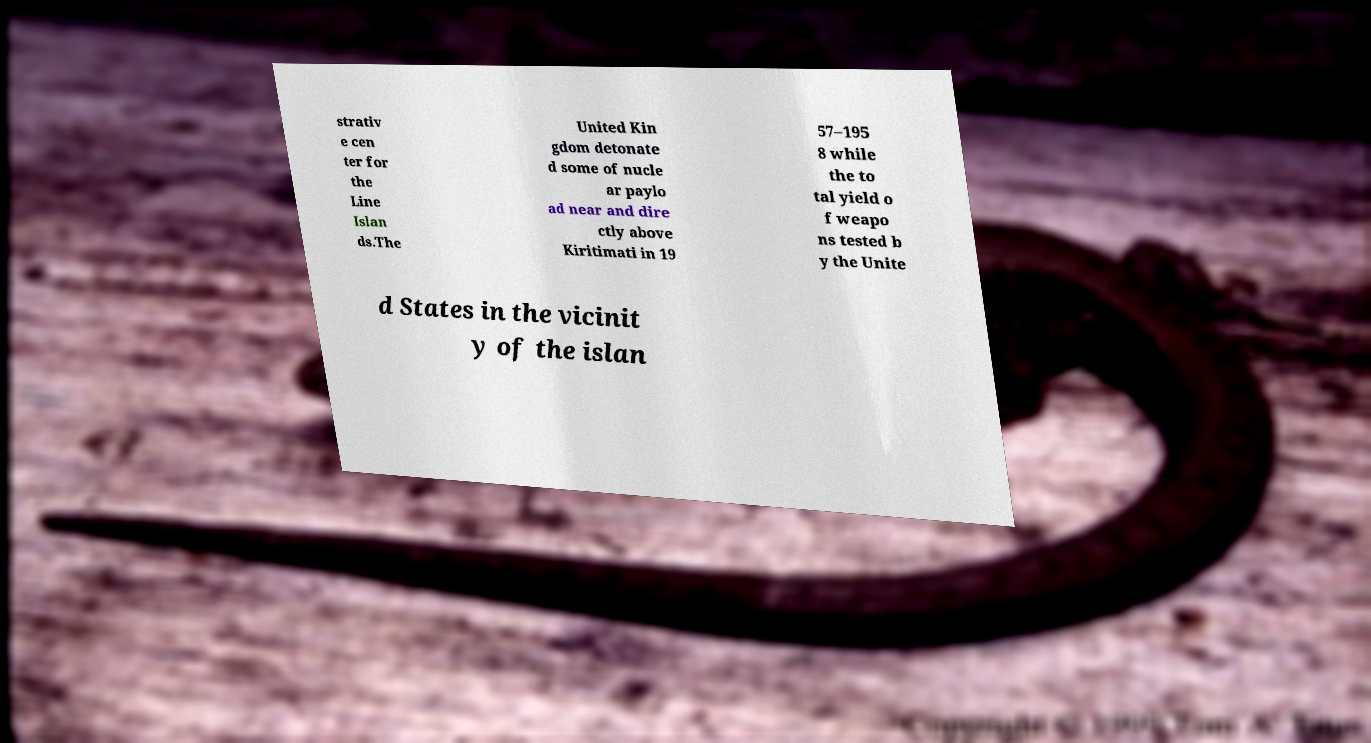Could you assist in decoding the text presented in this image and type it out clearly? strativ e cen ter for the Line Islan ds.The United Kin gdom detonate d some of nucle ar paylo ad near and dire ctly above Kiritimati in 19 57–195 8 while the to tal yield o f weapo ns tested b y the Unite d States in the vicinit y of the islan 